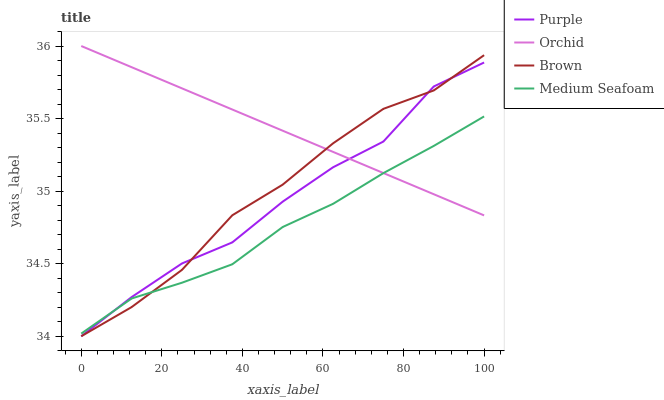Does Medium Seafoam have the minimum area under the curve?
Answer yes or no. Yes. Does Orchid have the maximum area under the curve?
Answer yes or no. Yes. Does Brown have the minimum area under the curve?
Answer yes or no. No. Does Brown have the maximum area under the curve?
Answer yes or no. No. Is Orchid the smoothest?
Answer yes or no. Yes. Is Purple the roughest?
Answer yes or no. Yes. Is Brown the smoothest?
Answer yes or no. No. Is Brown the roughest?
Answer yes or no. No. Does Purple have the lowest value?
Answer yes or no. Yes. Does Medium Seafoam have the lowest value?
Answer yes or no. No. Does Orchid have the highest value?
Answer yes or no. Yes. Does Brown have the highest value?
Answer yes or no. No. Does Purple intersect Medium Seafoam?
Answer yes or no. Yes. Is Purple less than Medium Seafoam?
Answer yes or no. No. Is Purple greater than Medium Seafoam?
Answer yes or no. No. 